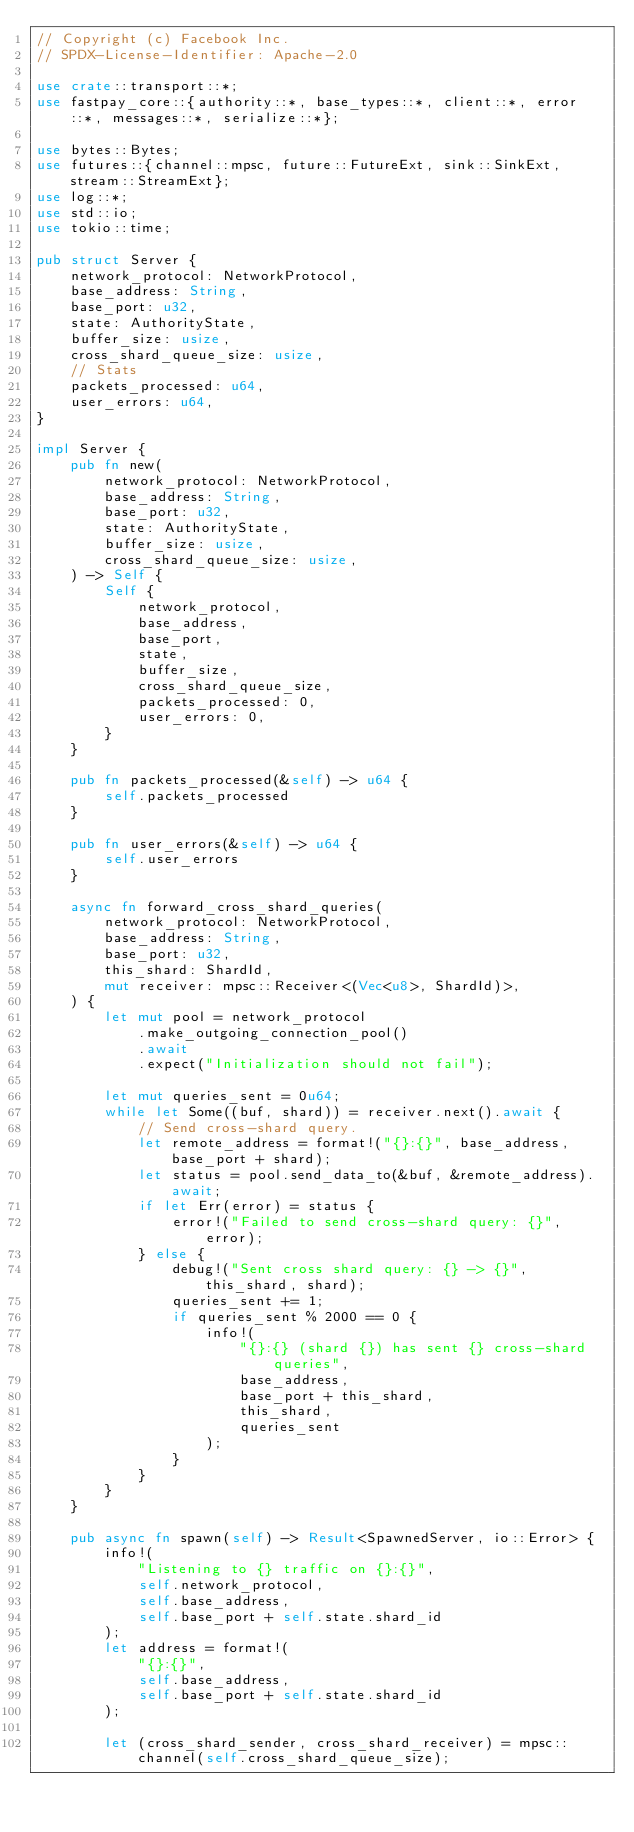<code> <loc_0><loc_0><loc_500><loc_500><_Rust_>// Copyright (c) Facebook Inc.
// SPDX-License-Identifier: Apache-2.0

use crate::transport::*;
use fastpay_core::{authority::*, base_types::*, client::*, error::*, messages::*, serialize::*};

use bytes::Bytes;
use futures::{channel::mpsc, future::FutureExt, sink::SinkExt, stream::StreamExt};
use log::*;
use std::io;
use tokio::time;

pub struct Server {
    network_protocol: NetworkProtocol,
    base_address: String,
    base_port: u32,
    state: AuthorityState,
    buffer_size: usize,
    cross_shard_queue_size: usize,
    // Stats
    packets_processed: u64,
    user_errors: u64,
}

impl Server {
    pub fn new(
        network_protocol: NetworkProtocol,
        base_address: String,
        base_port: u32,
        state: AuthorityState,
        buffer_size: usize,
        cross_shard_queue_size: usize,
    ) -> Self {
        Self {
            network_protocol,
            base_address,
            base_port,
            state,
            buffer_size,
            cross_shard_queue_size,
            packets_processed: 0,
            user_errors: 0,
        }
    }

    pub fn packets_processed(&self) -> u64 {
        self.packets_processed
    }

    pub fn user_errors(&self) -> u64 {
        self.user_errors
    }

    async fn forward_cross_shard_queries(
        network_protocol: NetworkProtocol,
        base_address: String,
        base_port: u32,
        this_shard: ShardId,
        mut receiver: mpsc::Receiver<(Vec<u8>, ShardId)>,
    ) {
        let mut pool = network_protocol
            .make_outgoing_connection_pool()
            .await
            .expect("Initialization should not fail");

        let mut queries_sent = 0u64;
        while let Some((buf, shard)) = receiver.next().await {
            // Send cross-shard query.
            let remote_address = format!("{}:{}", base_address, base_port + shard);
            let status = pool.send_data_to(&buf, &remote_address).await;
            if let Err(error) = status {
                error!("Failed to send cross-shard query: {}", error);
            } else {
                debug!("Sent cross shard query: {} -> {}", this_shard, shard);
                queries_sent += 1;
                if queries_sent % 2000 == 0 {
                    info!(
                        "{}:{} (shard {}) has sent {} cross-shard queries",
                        base_address,
                        base_port + this_shard,
                        this_shard,
                        queries_sent
                    );
                }
            }
        }
    }

    pub async fn spawn(self) -> Result<SpawnedServer, io::Error> {
        info!(
            "Listening to {} traffic on {}:{}",
            self.network_protocol,
            self.base_address,
            self.base_port + self.state.shard_id
        );
        let address = format!(
            "{}:{}",
            self.base_address,
            self.base_port + self.state.shard_id
        );

        let (cross_shard_sender, cross_shard_receiver) = mpsc::channel(self.cross_shard_queue_size);</code> 